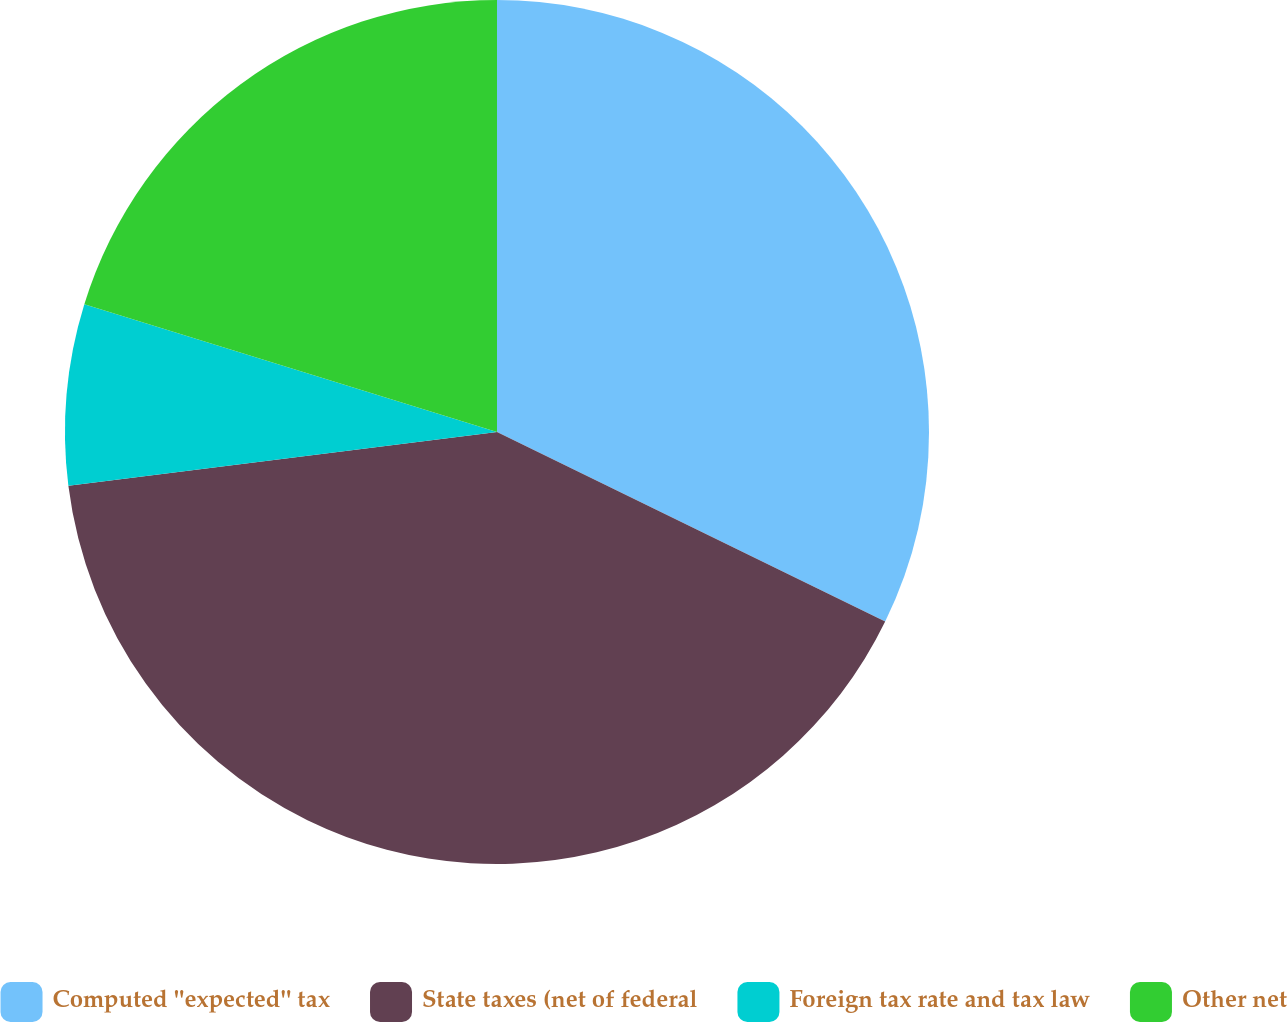<chart> <loc_0><loc_0><loc_500><loc_500><pie_chart><fcel>Computed ''expected'' tax<fcel>State taxes (net of federal<fcel>Foreign tax rate and tax law<fcel>Other net<nl><fcel>32.23%<fcel>40.78%<fcel>6.77%<fcel>20.22%<nl></chart> 